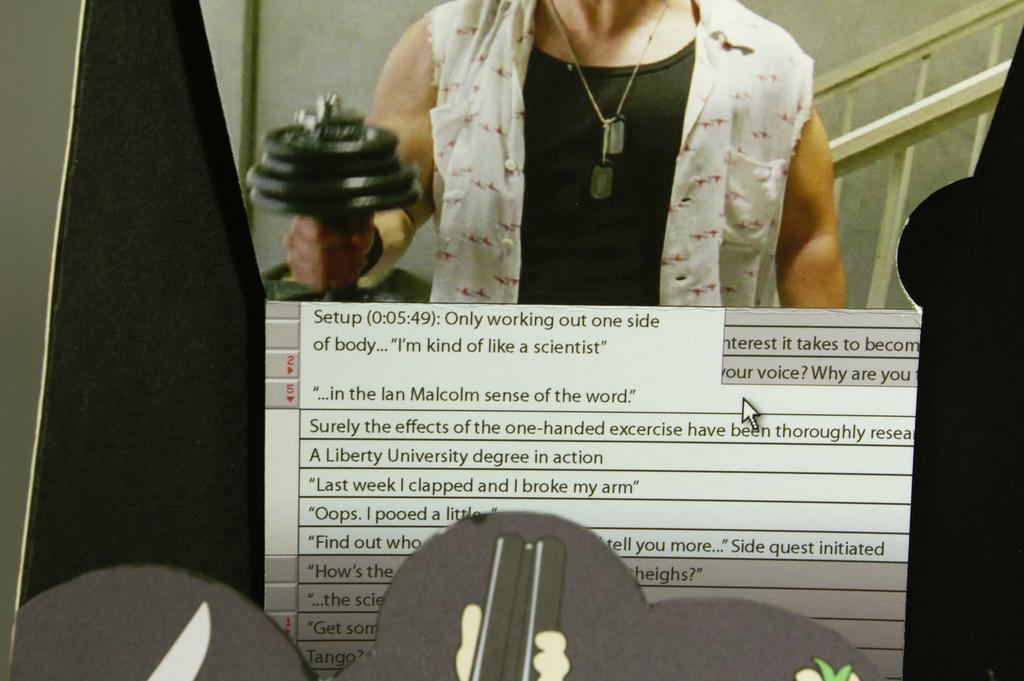Could you give a brief overview of what you see in this image? Here in this picture we can see a person holding dumbbell in his hand and behind him we can see a staircase and we can see this all is seen in a digital screen, as we can see options present with cursor over there. 